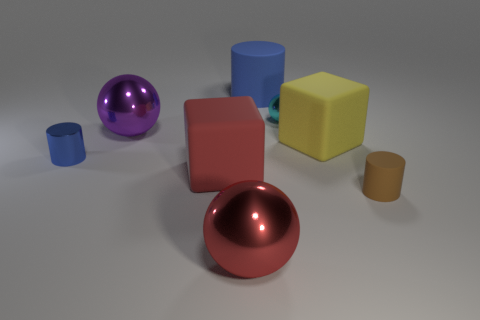Add 2 tiny cyan metallic things. How many objects exist? 10 Subtract all cubes. How many objects are left? 6 Add 7 small blue metal things. How many small blue metal things are left? 8 Add 8 blue metal cylinders. How many blue metal cylinders exist? 9 Subtract 0 cyan cubes. How many objects are left? 8 Subtract all tiny rubber cylinders. Subtract all large red balls. How many objects are left? 6 